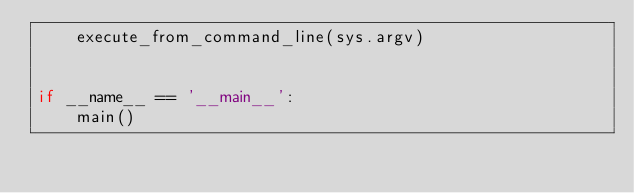<code> <loc_0><loc_0><loc_500><loc_500><_Python_>    execute_from_command_line(sys.argv)


if __name__ == '__main__':
    main()
</code> 